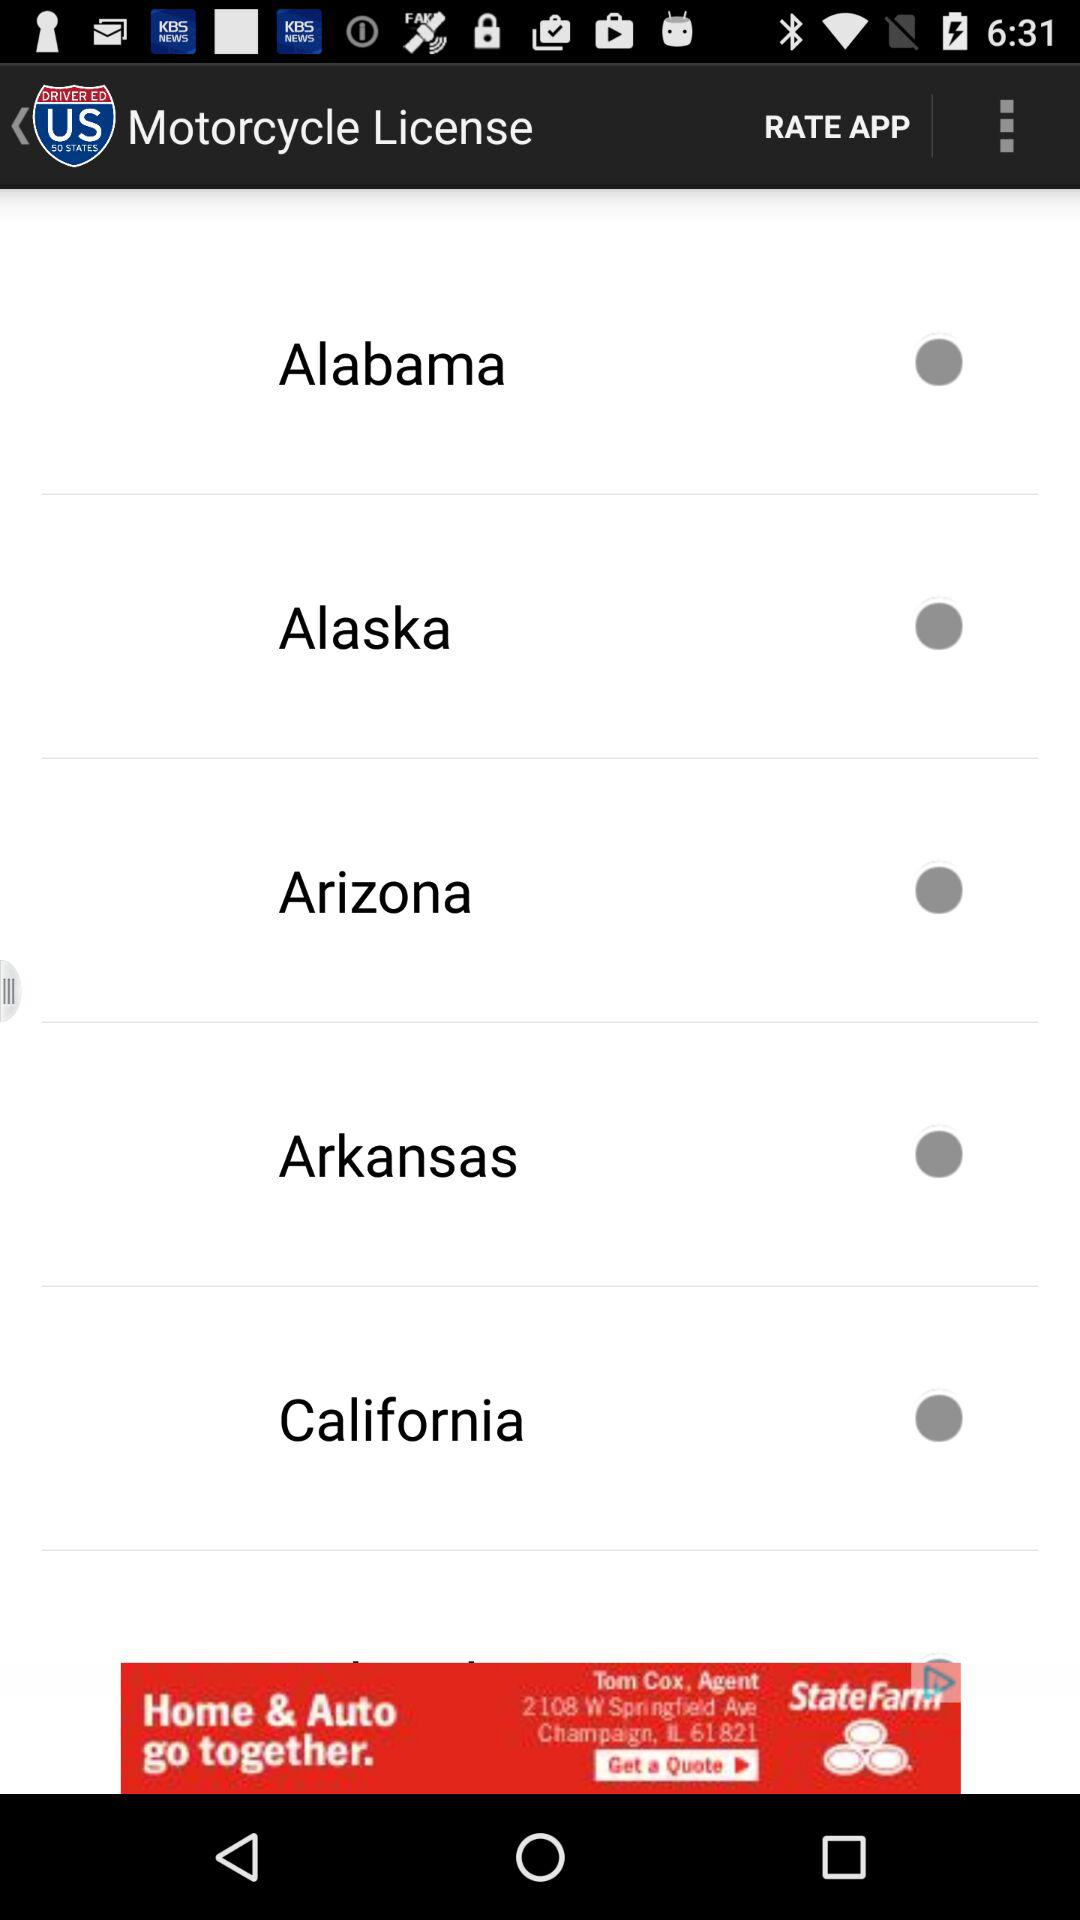What is the name of the application? The name of the application is "DMV Driver License Reviewer". 